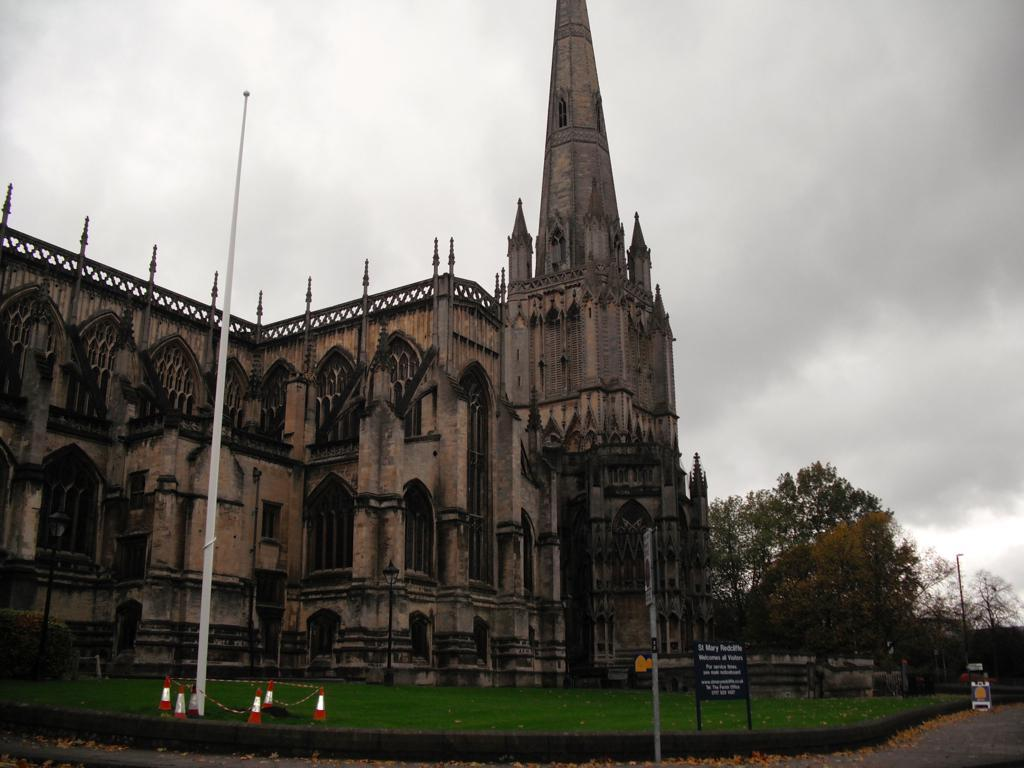What type of surface can be seen in the image? There is a road in the image. What type of vegetation is present in the image? There is grass in the image. What object can be seen in the image that might be used for displaying information or advertisements? There is a board in the image. What type of structures can be seen in the image? There are poles and a building with windows in the image. What objects are present in the image that are used to direct traffic or indicate construction? There are traffic cones in the image. What type of natural features can be seen in the image? There are trees in the image. What is visible in the background of the image? The sky is visible in the background of the image, and there are clouds in the sky. Can you see a pancake being flipped in the air in the image? No, there is no pancake present in the image. Is there a yak grazing in the grass in the image? No, there is no yak present in the image. 